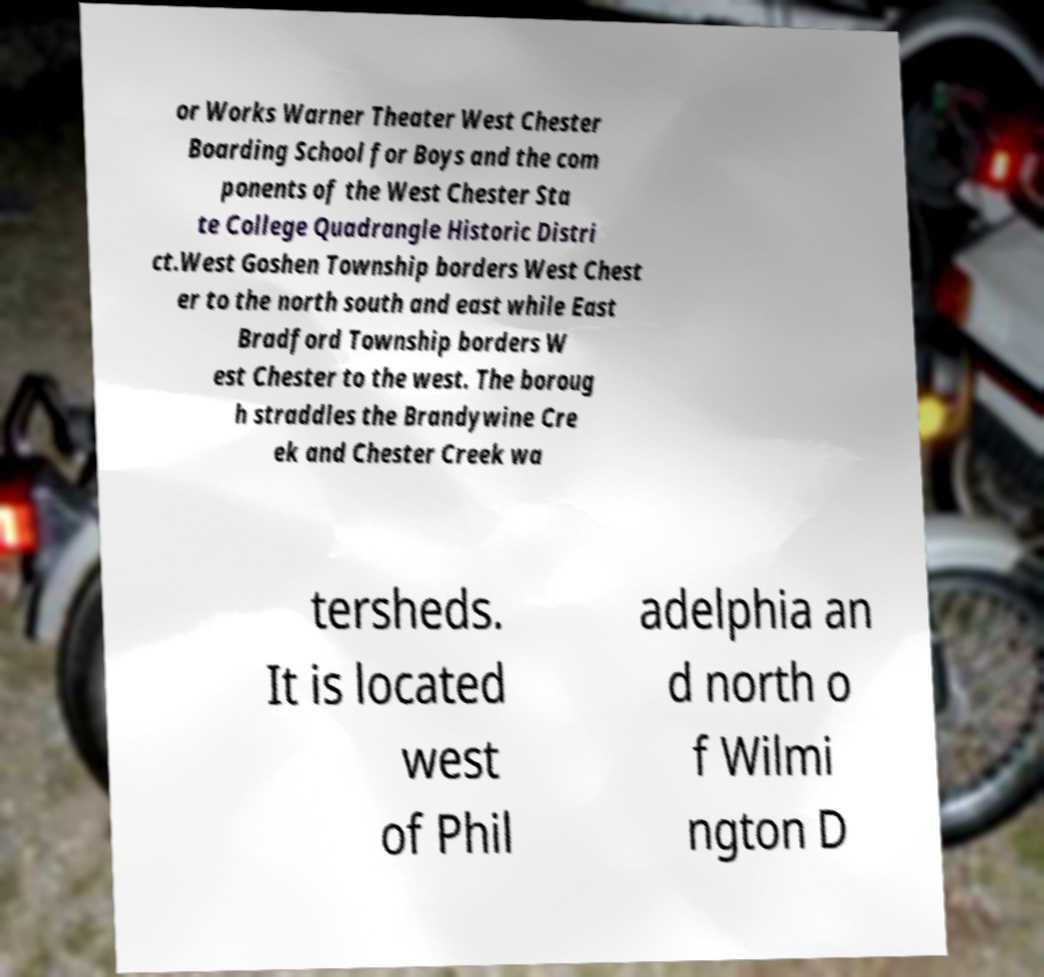What messages or text are displayed in this image? I need them in a readable, typed format. or Works Warner Theater West Chester Boarding School for Boys and the com ponents of the West Chester Sta te College Quadrangle Historic Distri ct.West Goshen Township borders West Chest er to the north south and east while East Bradford Township borders W est Chester to the west. The boroug h straddles the Brandywine Cre ek and Chester Creek wa tersheds. It is located west of Phil adelphia an d north o f Wilmi ngton D 